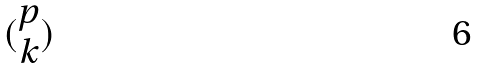Convert formula to latex. <formula><loc_0><loc_0><loc_500><loc_500>( \begin{matrix} p \\ k \end{matrix} )</formula> 